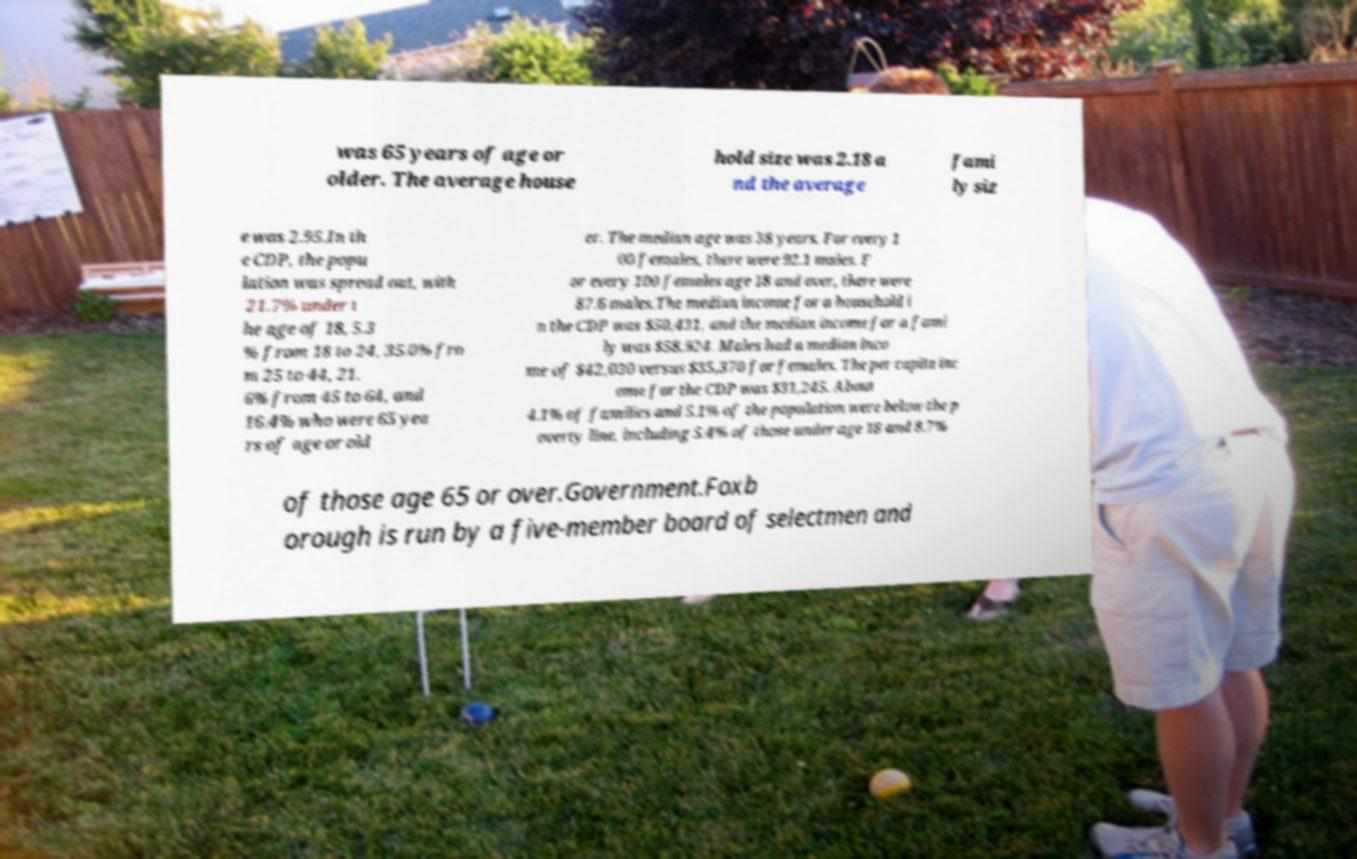There's text embedded in this image that I need extracted. Can you transcribe it verbatim? was 65 years of age or older. The average house hold size was 2.18 a nd the average fami ly siz e was 2.95.In th e CDP, the popu lation was spread out, with 21.7% under t he age of 18, 5.3 % from 18 to 24, 35.0% fro m 25 to 44, 21. 6% from 45 to 64, and 16.4% who were 65 yea rs of age or old er. The median age was 38 years. For every 1 00 females, there were 92.1 males. F or every 100 females age 18 and over, there were 87.6 males.The median income for a household i n the CDP was $50,431, and the median income for a fami ly was $58,924. Males had a median inco me of $42,030 versus $35,370 for females. The per capita inc ome for the CDP was $31,245. About 4.1% of families and 5.1% of the population were below the p overty line, including 5.4% of those under age 18 and 8.7% of those age 65 or over.Government.Foxb orough is run by a five-member board of selectmen and 